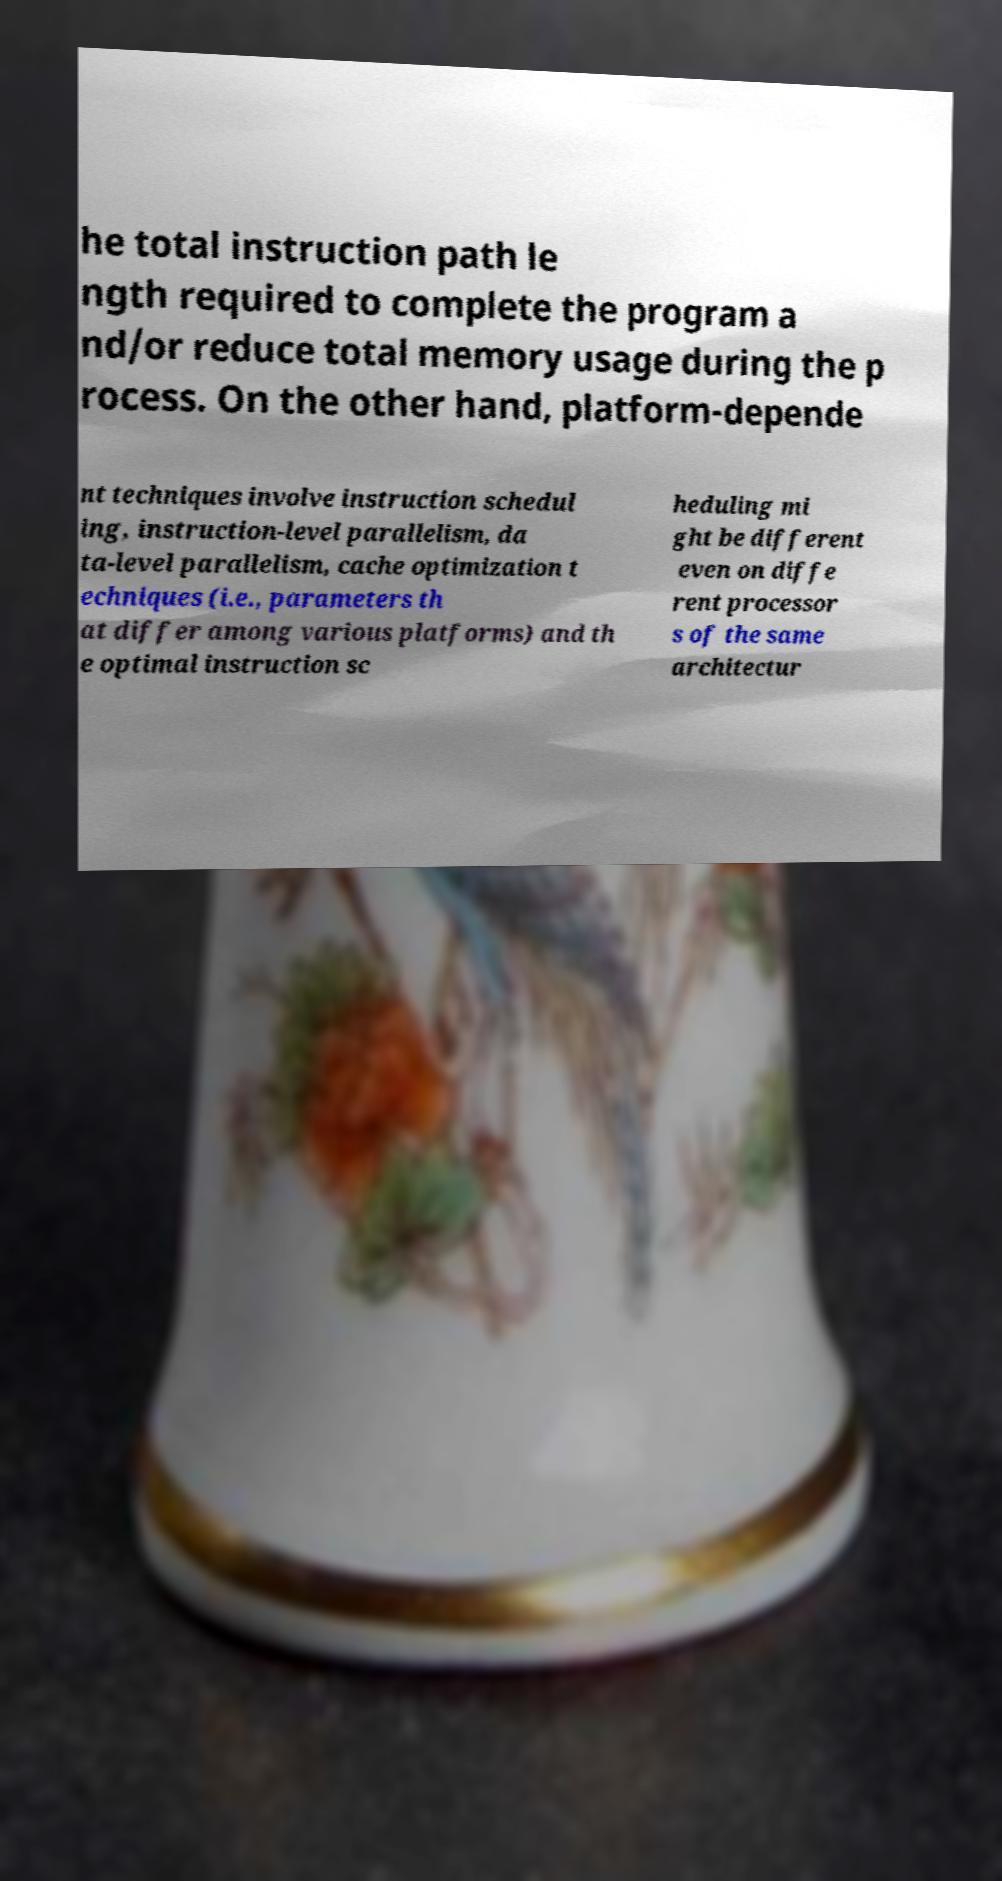Can you accurately transcribe the text from the provided image for me? he total instruction path le ngth required to complete the program a nd/or reduce total memory usage during the p rocess. On the other hand, platform-depende nt techniques involve instruction schedul ing, instruction-level parallelism, da ta-level parallelism, cache optimization t echniques (i.e., parameters th at differ among various platforms) and th e optimal instruction sc heduling mi ght be different even on diffe rent processor s of the same architectur 